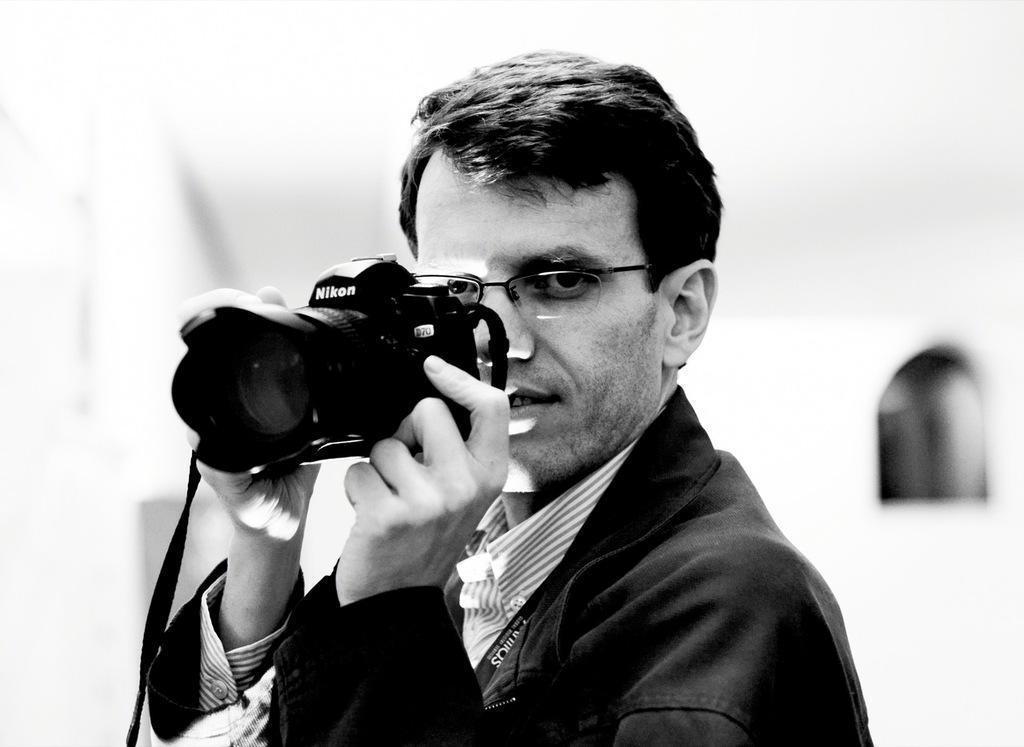Describe this image in one or two sentences. This is a black and white picture. Here we can see one man holding a camera in his hand. He wore spectacles. Background is very blurry. 